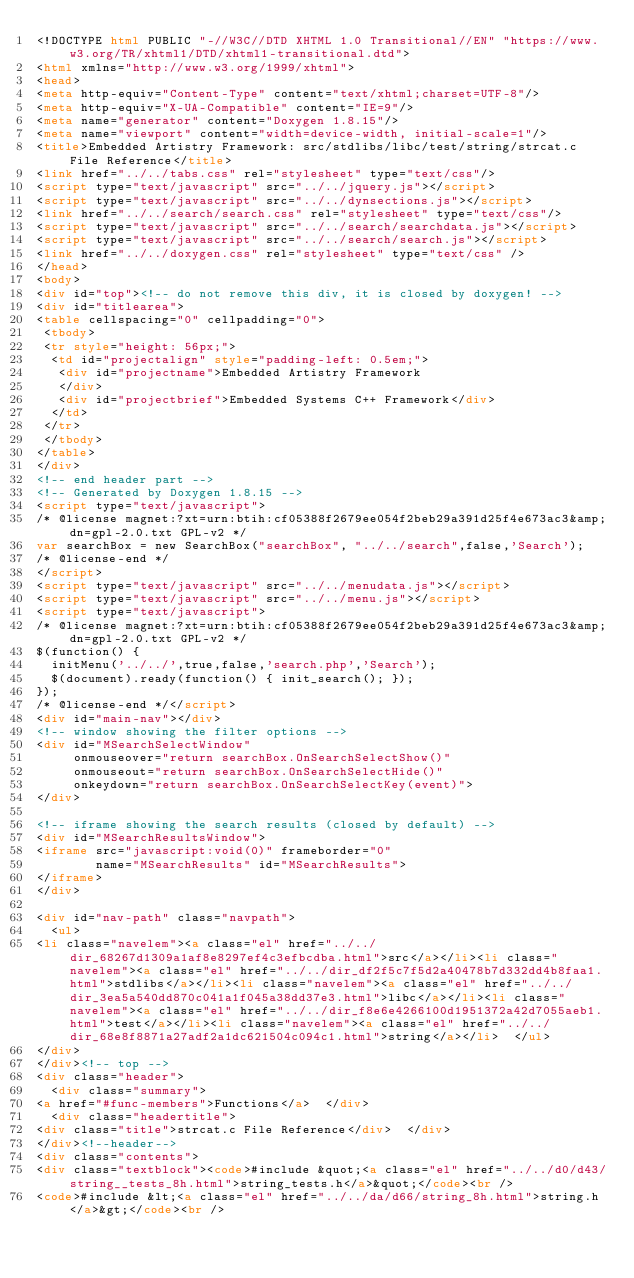Convert code to text. <code><loc_0><loc_0><loc_500><loc_500><_HTML_><!DOCTYPE html PUBLIC "-//W3C//DTD XHTML 1.0 Transitional//EN" "https://www.w3.org/TR/xhtml1/DTD/xhtml1-transitional.dtd">
<html xmlns="http://www.w3.org/1999/xhtml">
<head>
<meta http-equiv="Content-Type" content="text/xhtml;charset=UTF-8"/>
<meta http-equiv="X-UA-Compatible" content="IE=9"/>
<meta name="generator" content="Doxygen 1.8.15"/>
<meta name="viewport" content="width=device-width, initial-scale=1"/>
<title>Embedded Artistry Framework: src/stdlibs/libc/test/string/strcat.c File Reference</title>
<link href="../../tabs.css" rel="stylesheet" type="text/css"/>
<script type="text/javascript" src="../../jquery.js"></script>
<script type="text/javascript" src="../../dynsections.js"></script>
<link href="../../search/search.css" rel="stylesheet" type="text/css"/>
<script type="text/javascript" src="../../search/searchdata.js"></script>
<script type="text/javascript" src="../../search/search.js"></script>
<link href="../../doxygen.css" rel="stylesheet" type="text/css" />
</head>
<body>
<div id="top"><!-- do not remove this div, it is closed by doxygen! -->
<div id="titlearea">
<table cellspacing="0" cellpadding="0">
 <tbody>
 <tr style="height: 56px;">
  <td id="projectalign" style="padding-left: 0.5em;">
   <div id="projectname">Embedded Artistry Framework
   </div>
   <div id="projectbrief">Embedded Systems C++ Framework</div>
  </td>
 </tr>
 </tbody>
</table>
</div>
<!-- end header part -->
<!-- Generated by Doxygen 1.8.15 -->
<script type="text/javascript">
/* @license magnet:?xt=urn:btih:cf05388f2679ee054f2beb29a391d25f4e673ac3&amp;dn=gpl-2.0.txt GPL-v2 */
var searchBox = new SearchBox("searchBox", "../../search",false,'Search');
/* @license-end */
</script>
<script type="text/javascript" src="../../menudata.js"></script>
<script type="text/javascript" src="../../menu.js"></script>
<script type="text/javascript">
/* @license magnet:?xt=urn:btih:cf05388f2679ee054f2beb29a391d25f4e673ac3&amp;dn=gpl-2.0.txt GPL-v2 */
$(function() {
  initMenu('../../',true,false,'search.php','Search');
  $(document).ready(function() { init_search(); });
});
/* @license-end */</script>
<div id="main-nav"></div>
<!-- window showing the filter options -->
<div id="MSearchSelectWindow"
     onmouseover="return searchBox.OnSearchSelectShow()"
     onmouseout="return searchBox.OnSearchSelectHide()"
     onkeydown="return searchBox.OnSearchSelectKey(event)">
</div>

<!-- iframe showing the search results (closed by default) -->
<div id="MSearchResultsWindow">
<iframe src="javascript:void(0)" frameborder="0" 
        name="MSearchResults" id="MSearchResults">
</iframe>
</div>

<div id="nav-path" class="navpath">
  <ul>
<li class="navelem"><a class="el" href="../../dir_68267d1309a1af8e8297ef4c3efbcdba.html">src</a></li><li class="navelem"><a class="el" href="../../dir_df2f5c7f5d2a40478b7d332dd4b8faa1.html">stdlibs</a></li><li class="navelem"><a class="el" href="../../dir_3ea5a540dd870c041a1f045a38dd37e3.html">libc</a></li><li class="navelem"><a class="el" href="../../dir_f8e6e4266100d1951372a42d7055aeb1.html">test</a></li><li class="navelem"><a class="el" href="../../dir_68e8f8871a27adf2a1dc621504c094c1.html">string</a></li>  </ul>
</div>
</div><!-- top -->
<div class="header">
  <div class="summary">
<a href="#func-members">Functions</a>  </div>
  <div class="headertitle">
<div class="title">strcat.c File Reference</div>  </div>
</div><!--header-->
<div class="contents">
<div class="textblock"><code>#include &quot;<a class="el" href="../../d0/d43/string__tests_8h.html">string_tests.h</a>&quot;</code><br />
<code>#include &lt;<a class="el" href="../../da/d66/string_8h.html">string.h</a>&gt;</code><br /></code> 